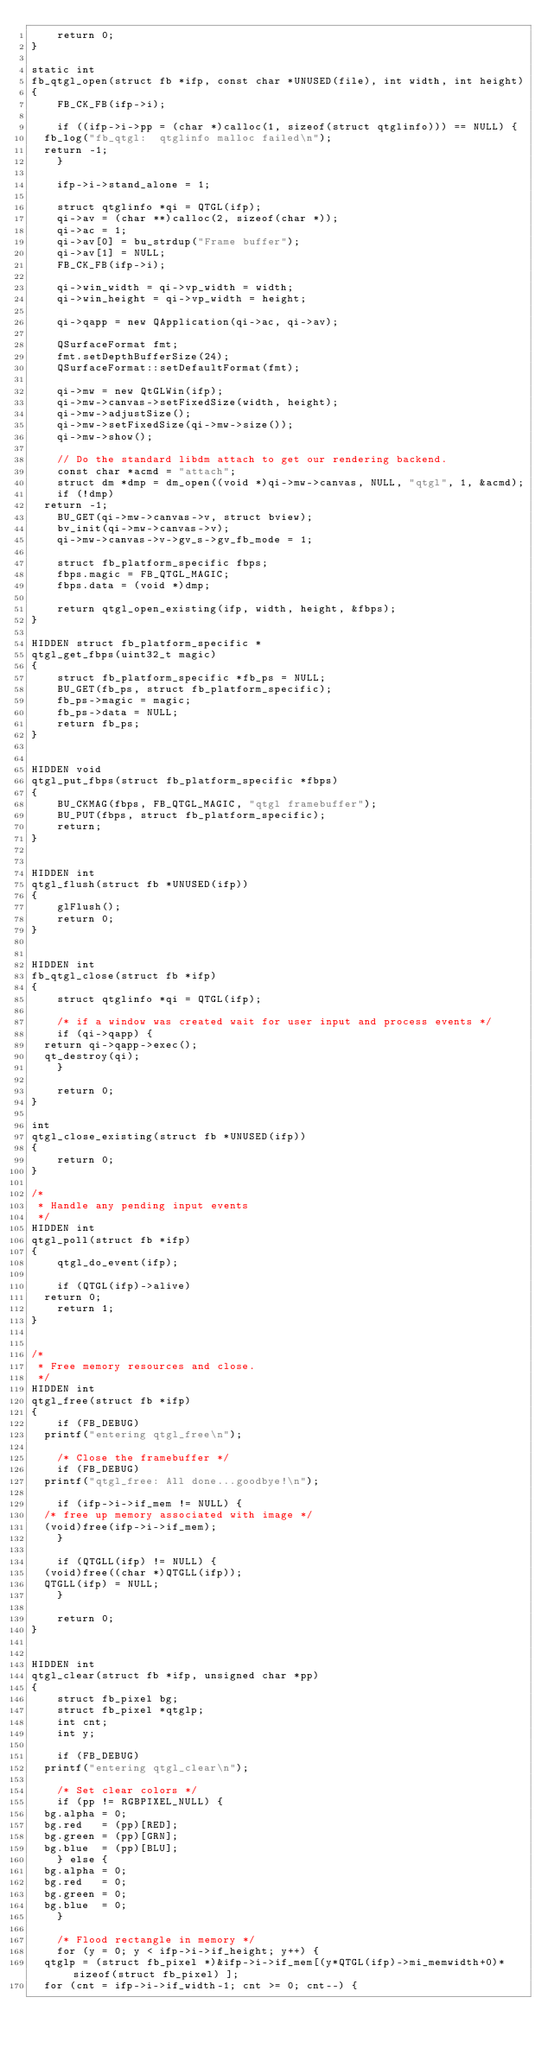<code> <loc_0><loc_0><loc_500><loc_500><_C++_>    return 0;
}

static int
fb_qtgl_open(struct fb *ifp, const char *UNUSED(file), int width, int height)
{
    FB_CK_FB(ifp->i);

    if ((ifp->i->pp = (char *)calloc(1, sizeof(struct qtglinfo))) == NULL) {
	fb_log("fb_qtgl:  qtglinfo malloc failed\n");
	return -1;
    }

    ifp->i->stand_alone = 1;

    struct qtglinfo *qi = QTGL(ifp);
    qi->av = (char **)calloc(2, sizeof(char *));
    qi->ac = 1;
    qi->av[0] = bu_strdup("Frame buffer");
    qi->av[1] = NULL;
    FB_CK_FB(ifp->i);

    qi->win_width = qi->vp_width = width;
    qi->win_height = qi->vp_width = height;

    qi->qapp = new QApplication(qi->ac, qi->av);

    QSurfaceFormat fmt;
    fmt.setDepthBufferSize(24);
    QSurfaceFormat::setDefaultFormat(fmt);

    qi->mw = new QtGLWin(ifp);
    qi->mw->canvas->setFixedSize(width, height);
    qi->mw->adjustSize();
    qi->mw->setFixedSize(qi->mw->size());
    qi->mw->show();

    // Do the standard libdm attach to get our rendering backend.
    const char *acmd = "attach";
    struct dm *dmp = dm_open((void *)qi->mw->canvas, NULL, "qtgl", 1, &acmd);
    if (!dmp)
	return -1;
    BU_GET(qi->mw->canvas->v, struct bview);
    bv_init(qi->mw->canvas->v);
    qi->mw->canvas->v->gv_s->gv_fb_mode = 1;

    struct fb_platform_specific fbps;
    fbps.magic = FB_QTGL_MAGIC;
    fbps.data = (void *)dmp;

    return qtgl_open_existing(ifp, width, height, &fbps);
}

HIDDEN struct fb_platform_specific *
qtgl_get_fbps(uint32_t magic)
{
    struct fb_platform_specific *fb_ps = NULL;
    BU_GET(fb_ps, struct fb_platform_specific);
    fb_ps->magic = magic;
    fb_ps->data = NULL;
    return fb_ps;
}


HIDDEN void
qtgl_put_fbps(struct fb_platform_specific *fbps)
{
    BU_CKMAG(fbps, FB_QTGL_MAGIC, "qtgl framebuffer");
    BU_PUT(fbps, struct fb_platform_specific);
    return;
}


HIDDEN int
qtgl_flush(struct fb *UNUSED(ifp))
{
    glFlush();
    return 0;
}


HIDDEN int
fb_qtgl_close(struct fb *ifp)
{
    struct qtglinfo *qi = QTGL(ifp);

    /* if a window was created wait for user input and process events */
    if (qi->qapp) {
	return qi->qapp->exec();
	qt_destroy(qi);
    }

    return 0;
}

int
qtgl_close_existing(struct fb *UNUSED(ifp))
{
    return 0;
}

/*
 * Handle any pending input events
 */
HIDDEN int
qtgl_poll(struct fb *ifp)
{
    qtgl_do_event(ifp);

    if (QTGL(ifp)->alive)
	return 0;
    return 1;
}


/*
 * Free memory resources and close.
 */
HIDDEN int
qtgl_free(struct fb *ifp)
{
    if (FB_DEBUG)
	printf("entering qtgl_free\n");

    /* Close the framebuffer */
    if (FB_DEBUG)
	printf("qtgl_free: All done...goodbye!\n");

    if (ifp->i->if_mem != NULL) {
	/* free up memory associated with image */
	(void)free(ifp->i->if_mem);
    }

    if (QTGLL(ifp) != NULL) {
	(void)free((char *)QTGLL(ifp));
	QTGLL(ifp) = NULL;
    }

    return 0;
}


HIDDEN int
qtgl_clear(struct fb *ifp, unsigned char *pp)
{
    struct fb_pixel bg;
    struct fb_pixel *qtglp;
    int cnt;
    int y;

    if (FB_DEBUG)
	printf("entering qtgl_clear\n");

    /* Set clear colors */
    if (pp != RGBPIXEL_NULL) {
	bg.alpha = 0;
	bg.red   = (pp)[RED];
	bg.green = (pp)[GRN];
	bg.blue  = (pp)[BLU];
    } else {
	bg.alpha = 0;
	bg.red   = 0;
	bg.green = 0;
	bg.blue  = 0;
    }

    /* Flood rectangle in memory */
    for (y = 0; y < ifp->i->if_height; y++) {
	qtglp = (struct fb_pixel *)&ifp->i->if_mem[(y*QTGL(ifp)->mi_memwidth+0)*sizeof(struct fb_pixel) ];
	for (cnt = ifp->i->if_width-1; cnt >= 0; cnt--) {</code> 